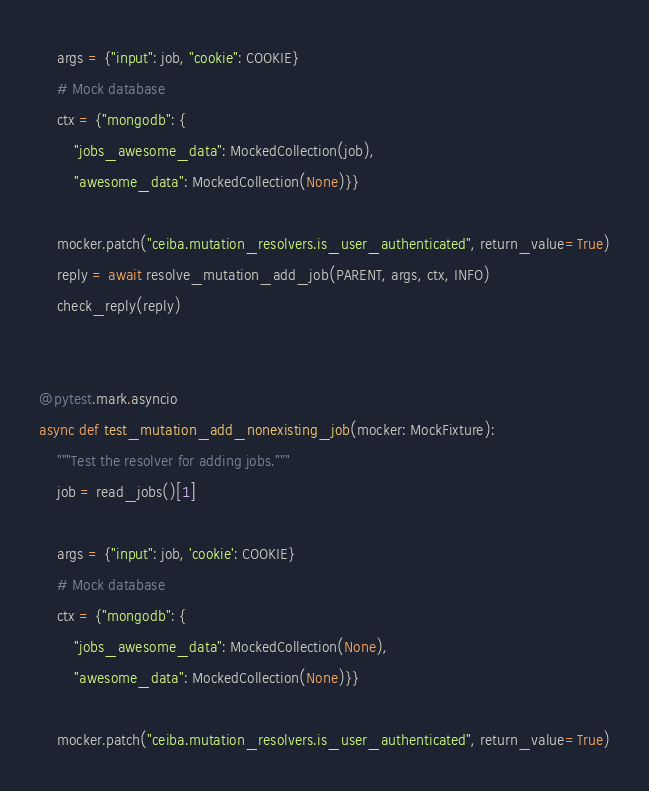Convert code to text. <code><loc_0><loc_0><loc_500><loc_500><_Python_>
    args = {"input": job, "cookie": COOKIE}
    # Mock database
    ctx = {"mongodb": {
        "jobs_awesome_data": MockedCollection(job),
        "awesome_data": MockedCollection(None)}}

    mocker.patch("ceiba.mutation_resolvers.is_user_authenticated", return_value=True)
    reply = await resolve_mutation_add_job(PARENT, args, ctx, INFO)
    check_reply(reply)


@pytest.mark.asyncio
async def test_mutation_add_nonexisting_job(mocker: MockFixture):
    """Test the resolver for adding jobs."""
    job = read_jobs()[1]

    args = {"input": job, 'cookie': COOKIE}
    # Mock database
    ctx = {"mongodb": {
        "jobs_awesome_data": MockedCollection(None),
        "awesome_data": MockedCollection(None)}}

    mocker.patch("ceiba.mutation_resolvers.is_user_authenticated", return_value=True)</code> 